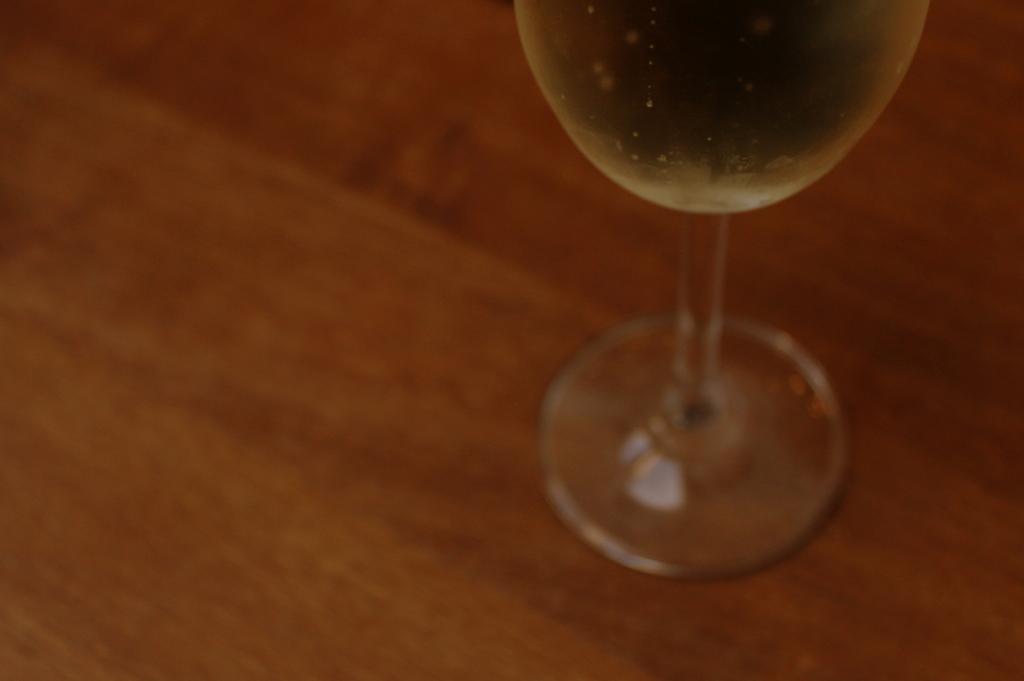Could you give a brief overview of what you see in this image? In this image there is one glass kept on a wooden surface as we can see in the middle of this image. 